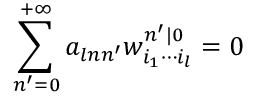Convert formula to latex. <formula><loc_0><loc_0><loc_500><loc_500>\sum _ { n ^ { \prime } = 0 } ^ { + \infty } a _ { \ln n ^ { \prime } } w _ { i _ { 1 } \cdots i _ { l } } ^ { n ^ { \prime } | 0 } = 0</formula> 